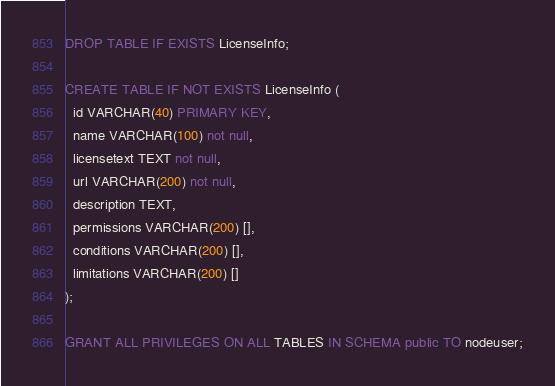<code> <loc_0><loc_0><loc_500><loc_500><_SQL_>DROP TABLE IF EXISTS LicenseInfo;

CREATE TABLE IF NOT EXISTS LicenseInfo (
  id VARCHAR(40) PRIMARY KEY,
  name VARCHAR(100) not null,
  licensetext TEXT not null,
  url VARCHAR(200) not null,
  description TEXT,
  permissions VARCHAR(200) [],
  conditions VARCHAR(200) [],
  limitations VARCHAR(200) []
);

GRANT ALL PRIVILEGES ON ALL TABLES IN SCHEMA public TO nodeuser;
</code> 